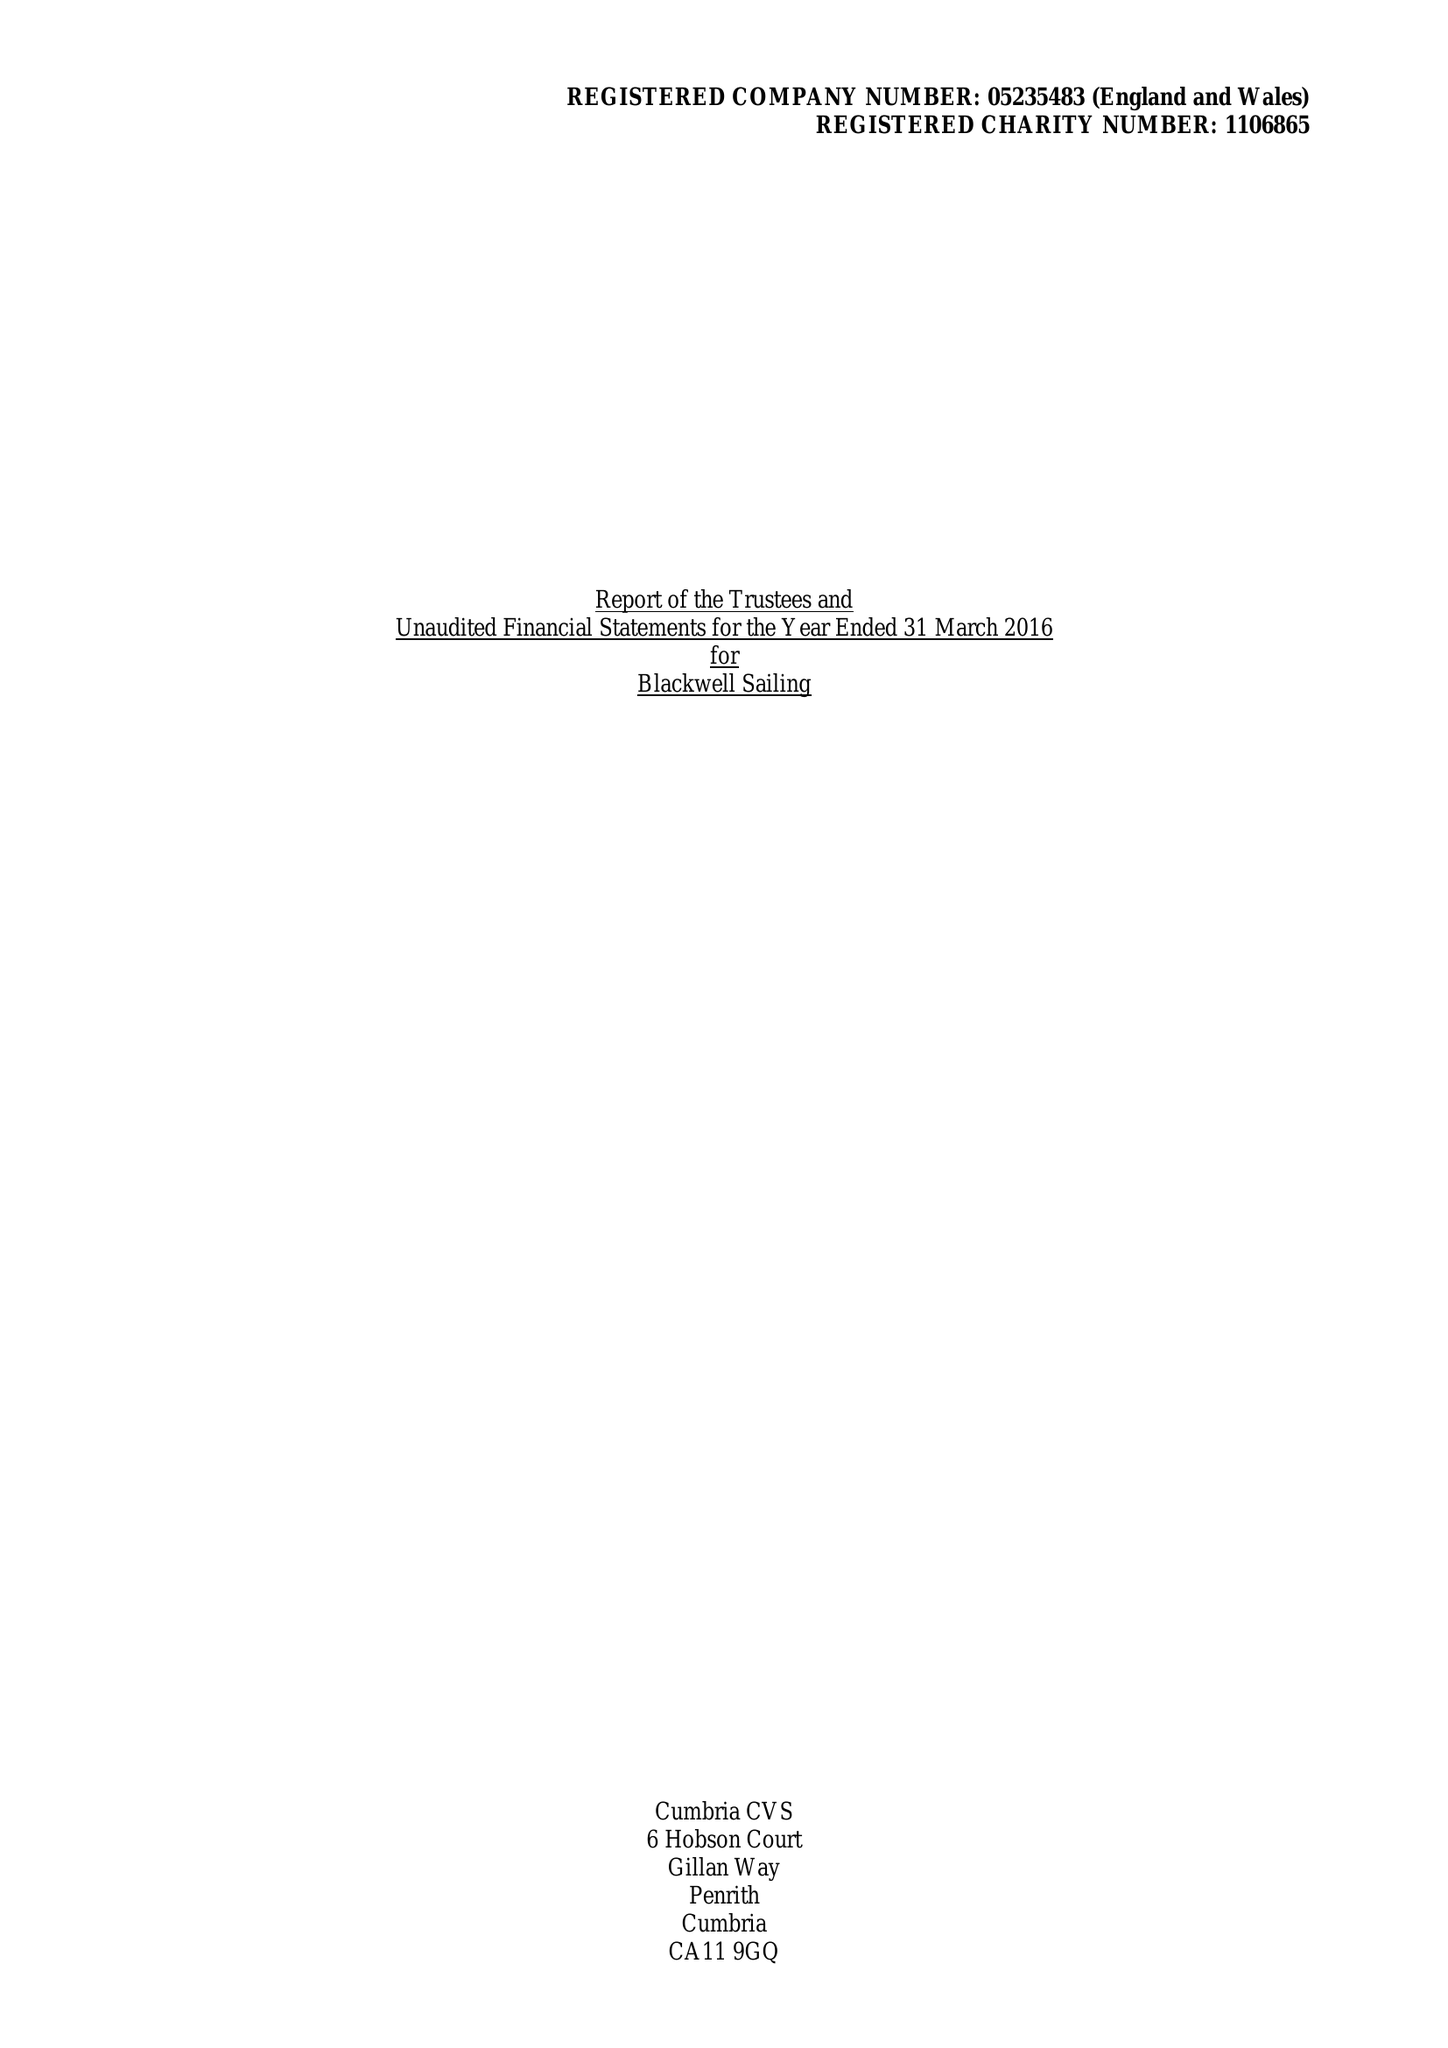What is the value for the report_date?
Answer the question using a single word or phrase. 2016-03-31 